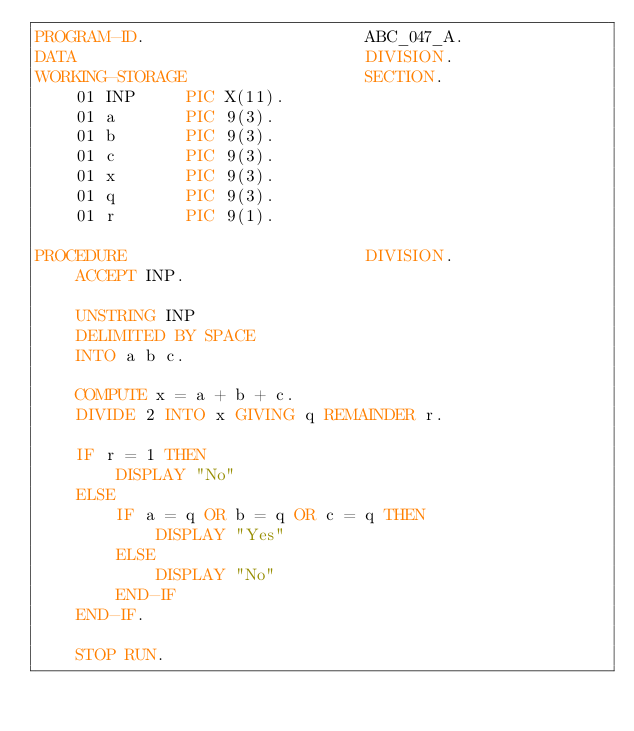<code> <loc_0><loc_0><loc_500><loc_500><_COBOL_>PROGRAM-ID.                      ABC_047_A.
DATA                             DIVISION.
WORKING-STORAGE                  SECTION.
    01 INP     PIC X(11).
    01 a       PIC 9(3).
    01 b       PIC 9(3).
    01 c       PIC 9(3).
    01 x       PIC 9(3).
    01 q       PIC 9(3).
    01 r       PIC 9(1).

PROCEDURE                        DIVISION.
    ACCEPT INP.

    UNSTRING INP
    DELIMITED BY SPACE
    INTO a b c.

    COMPUTE x = a + b + c.
    DIVIDE 2 INTO x GIVING q REMAINDER r.

    IF r = 1 THEN
        DISPLAY "No"
    ELSE
        IF a = q OR b = q OR c = q THEN
            DISPLAY "Yes"
        ELSE
            DISPLAY "No"
        END-IF
    END-IF.

    STOP RUN.
</code> 